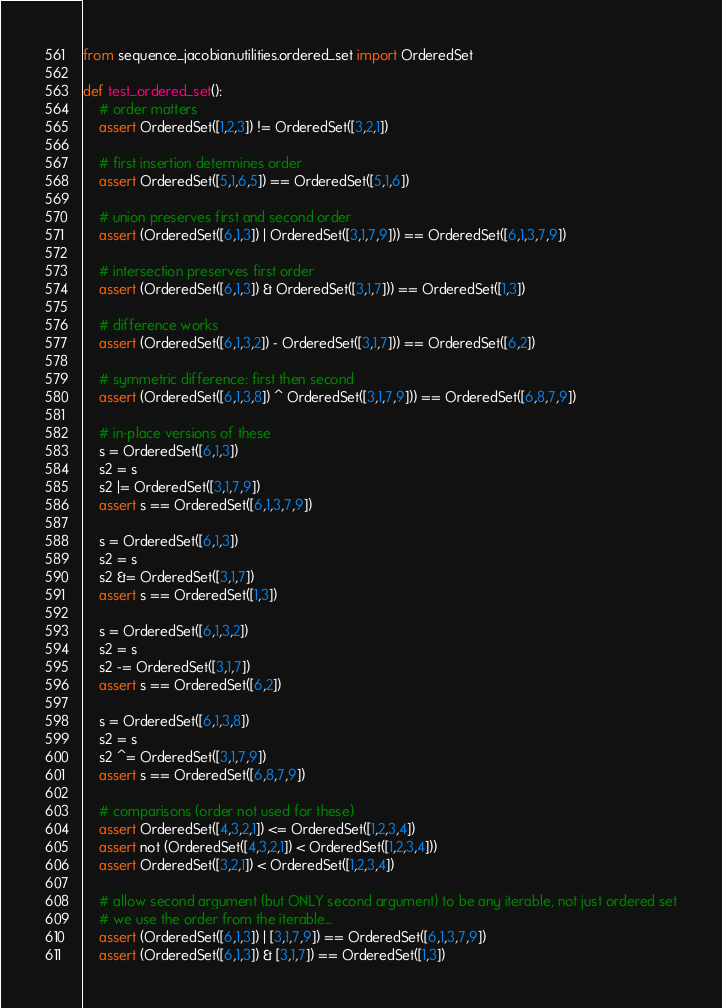Convert code to text. <code><loc_0><loc_0><loc_500><loc_500><_Python_>from sequence_jacobian.utilities.ordered_set import OrderedSet

def test_ordered_set():
    # order matters
    assert OrderedSet([1,2,3]) != OrderedSet([3,2,1]) 

    # first insertion determines order
    assert OrderedSet([5,1,6,5]) == OrderedSet([5,1,6])

    # union preserves first and second order
    assert (OrderedSet([6,1,3]) | OrderedSet([3,1,7,9])) == OrderedSet([6,1,3,7,9])

    # intersection preserves first order
    assert (OrderedSet([6,1,3]) & OrderedSet([3,1,7])) == OrderedSet([1,3])

    # difference works
    assert (OrderedSet([6,1,3,2]) - OrderedSet([3,1,7])) == OrderedSet([6,2])

    # symmetric difference: first then second
    assert (OrderedSet([6,1,3,8]) ^ OrderedSet([3,1,7,9])) == OrderedSet([6,8,7,9])

    # in-place versions of these
    s = OrderedSet([6,1,3])
    s2 = s
    s2 |= OrderedSet([3,1,7,9])
    assert s == OrderedSet([6,1,3,7,9])

    s = OrderedSet([6,1,3])
    s2 = s
    s2 &= OrderedSet([3,1,7])
    assert s == OrderedSet([1,3])

    s = OrderedSet([6,1,3,2])
    s2 = s
    s2 -= OrderedSet([3,1,7])
    assert s == OrderedSet([6,2])

    s = OrderedSet([6,1,3,8])
    s2 = s
    s2 ^= OrderedSet([3,1,7,9])
    assert s == OrderedSet([6,8,7,9])

    # comparisons (order not used for these)
    assert OrderedSet([4,3,2,1]) <= OrderedSet([1,2,3,4])
    assert not (OrderedSet([4,3,2,1]) < OrderedSet([1,2,3,4]))
    assert OrderedSet([3,2,1]) < OrderedSet([1,2,3,4])

    # allow second argument (but ONLY second argument) to be any iterable, not just ordered set
    # we use the order from the iterable...
    assert (OrderedSet([6,1,3]) | [3,1,7,9]) == OrderedSet([6,1,3,7,9])
    assert (OrderedSet([6,1,3]) & [3,1,7]) == OrderedSet([1,3])</code> 